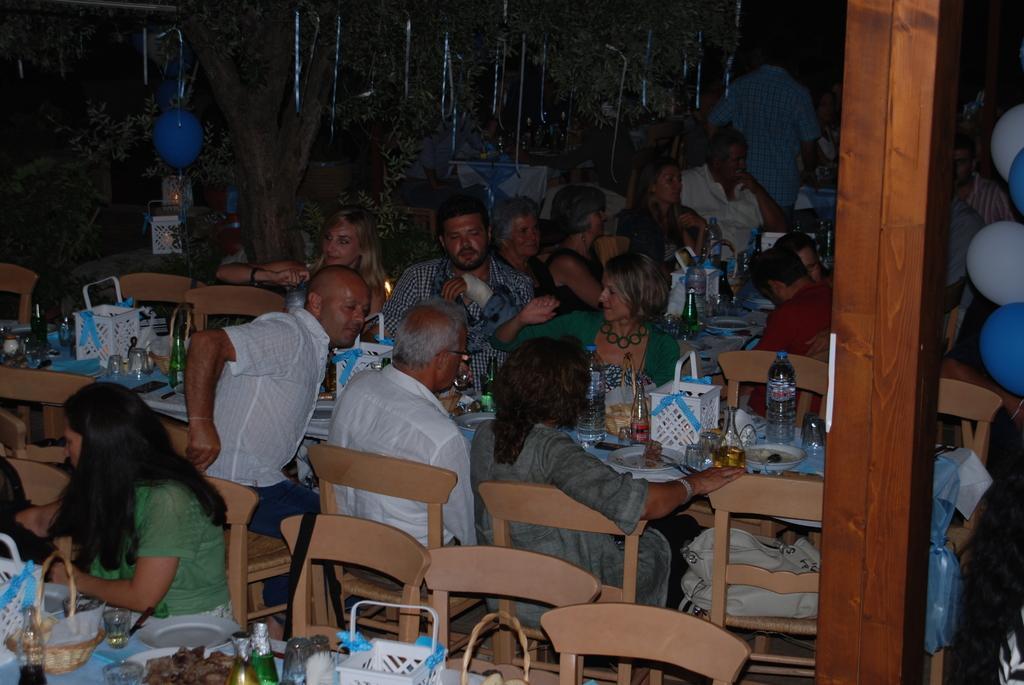How would you summarize this image in a sentence or two? Background is dark. we can see persons sitting on chairs in front of a table and on the table we can see bottles, baskets, tissue papers, plate of food, glasses. At the right side of the picture we can see balloons in white and blue colour. 